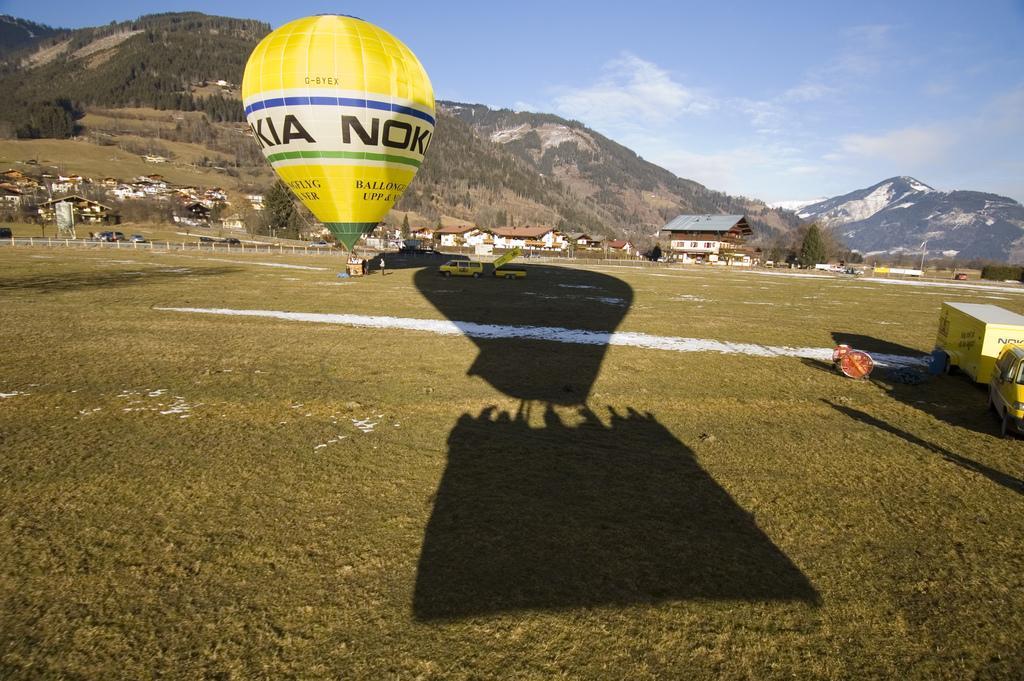Describe this image in one or two sentences. In this picture there are houses and trees in the center of the image and there is grassland at the bottom side of the image, there is a truck on the right side of the image and there is a hot air balloon at the top side of the image. 